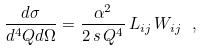<formula> <loc_0><loc_0><loc_500><loc_500>\frac { d \sigma } { d ^ { 4 } Q d \Omega } = \frac { \alpha ^ { 2 } } { 2 \, s \, Q ^ { 4 } } \, L _ { i j } \, W _ { i j } \ ,</formula> 